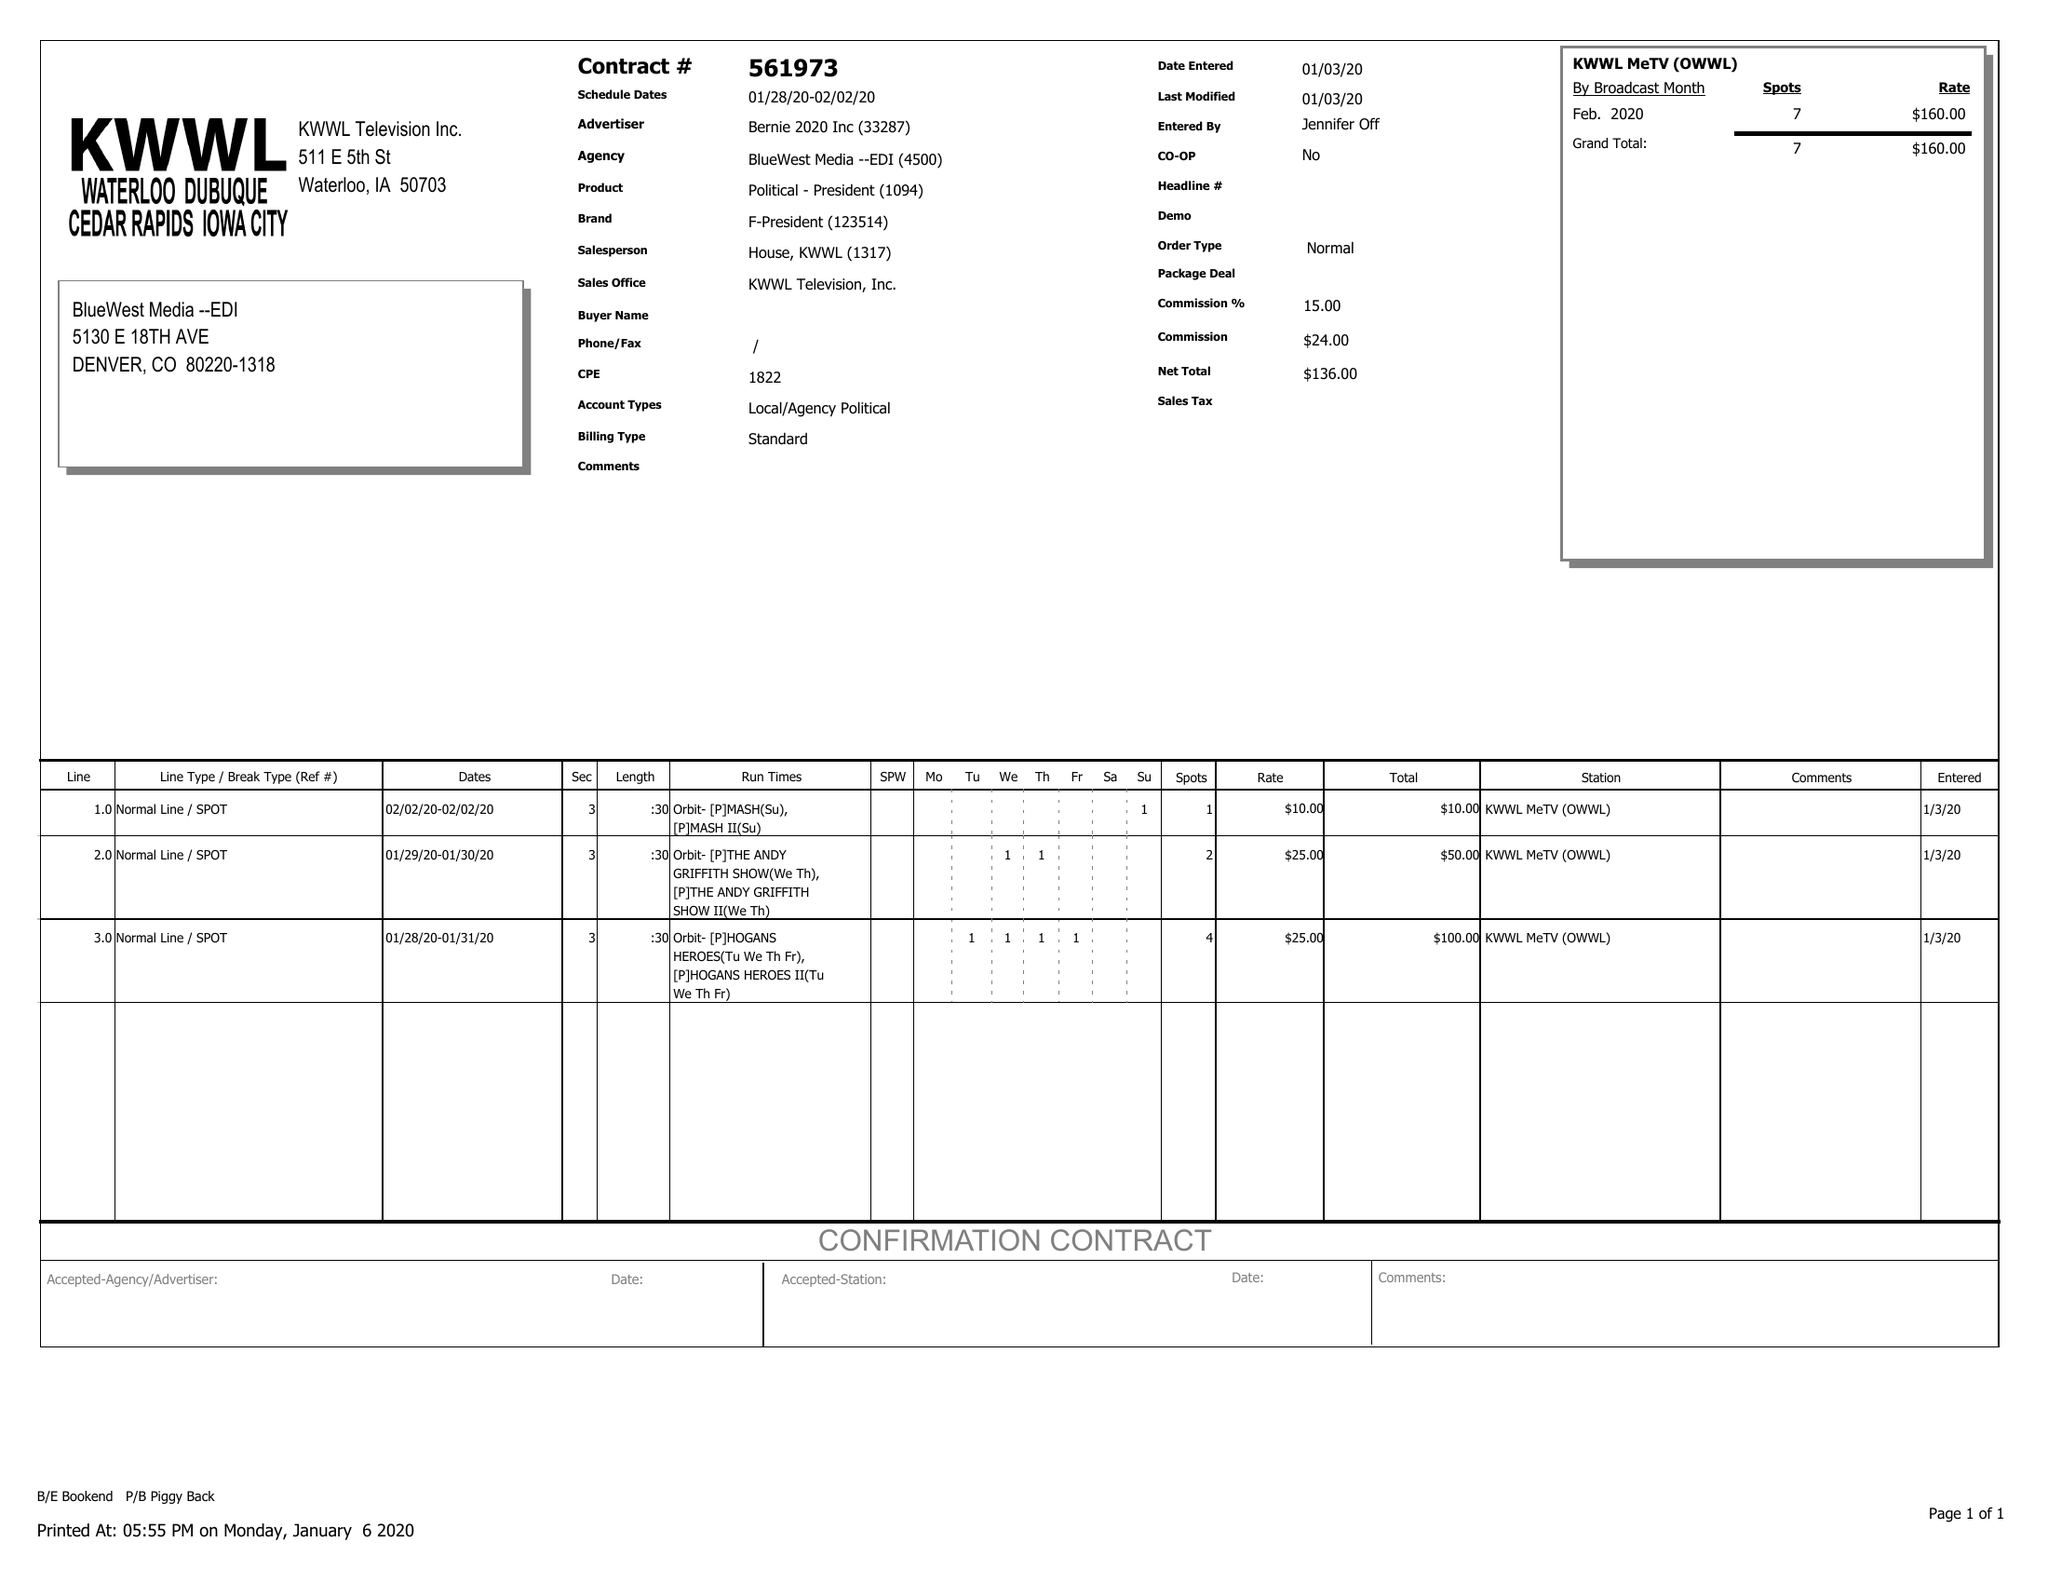What is the value for the contract_num?
Answer the question using a single word or phrase. 561973 